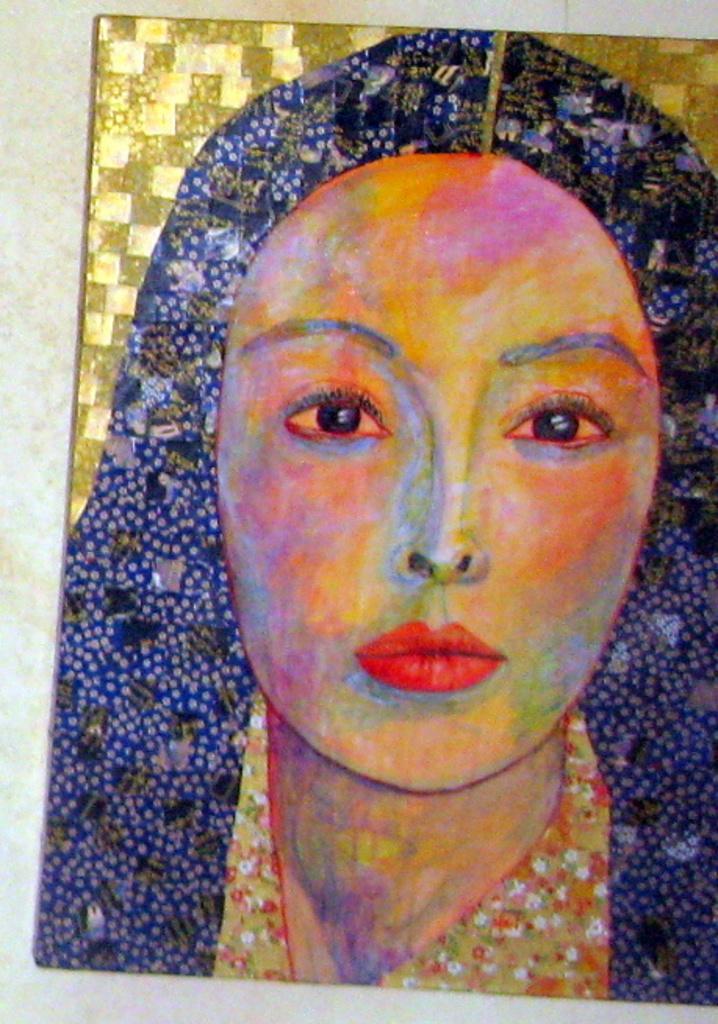Can you describe this image briefly? In this picture we can see a painting. 